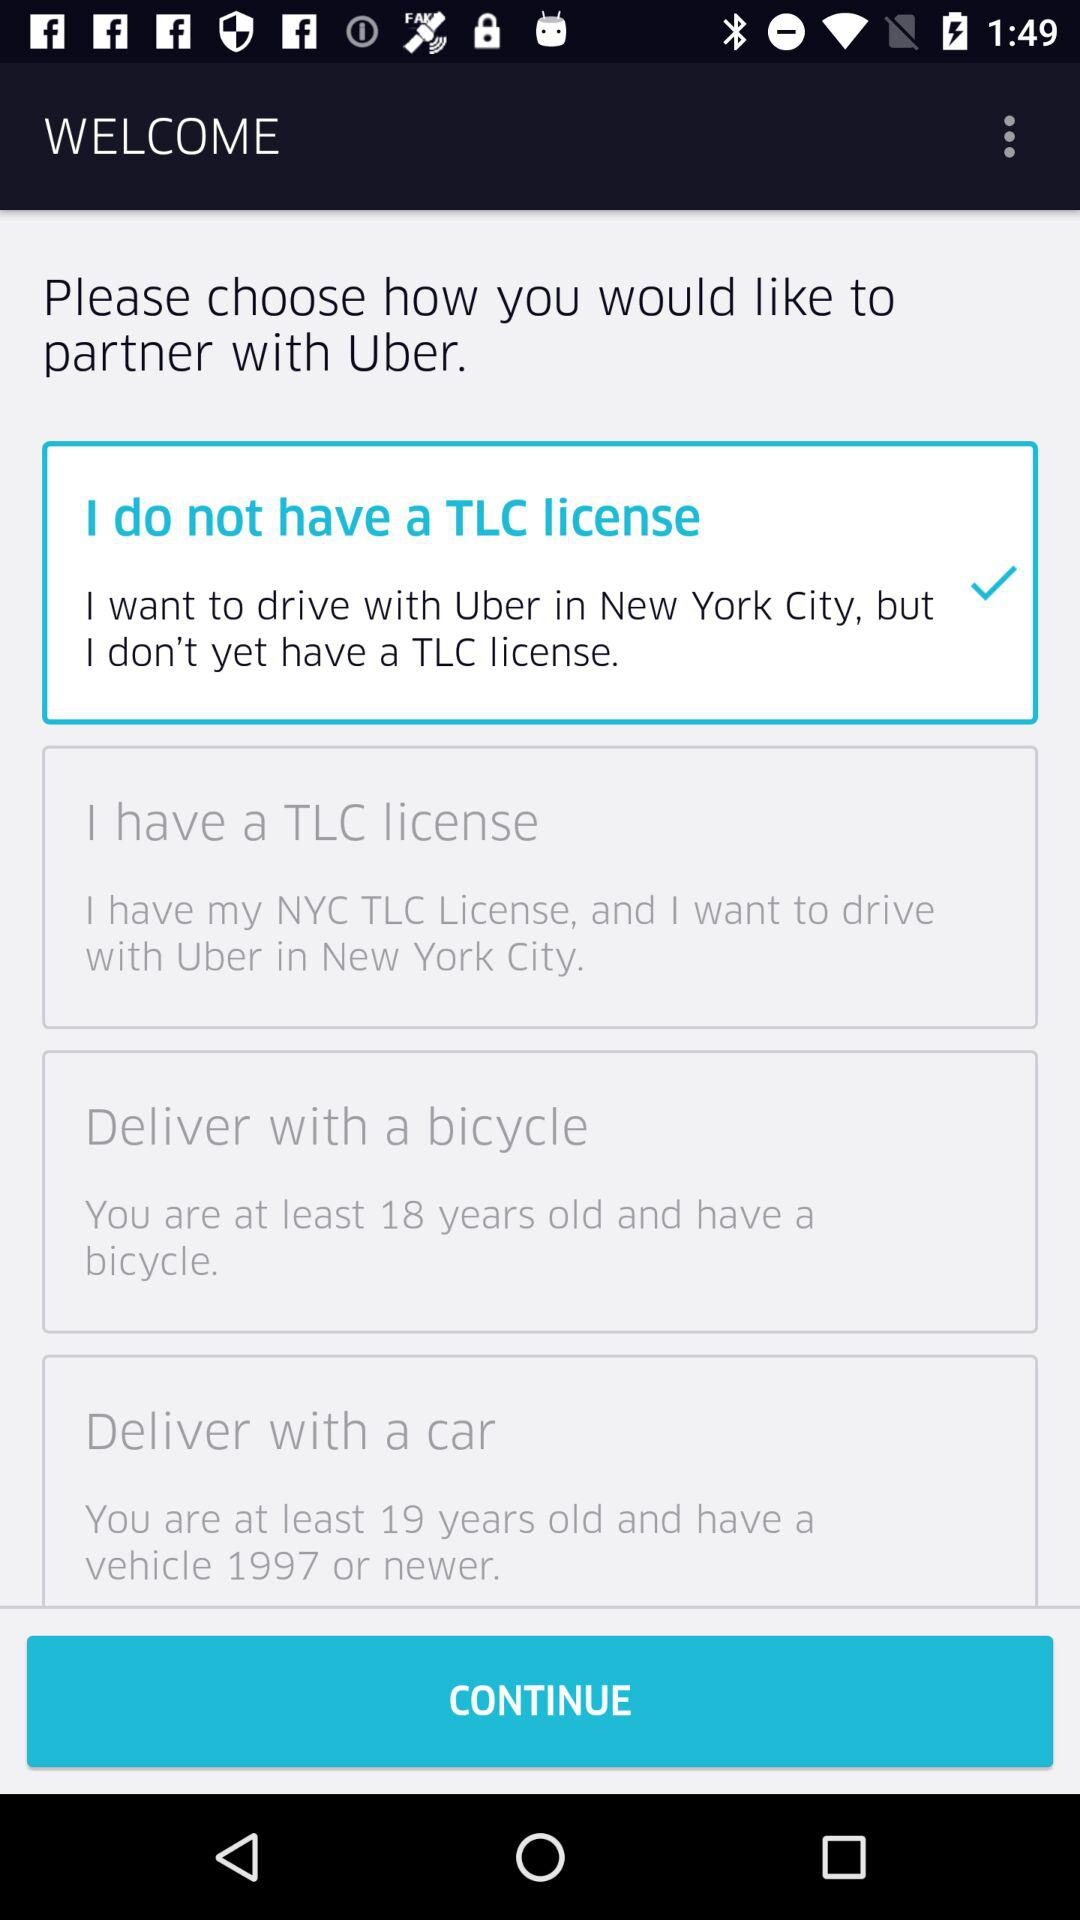What is the least age to have a bicycle?
When the provided information is insufficient, respond with <no answer>. <no answer> 